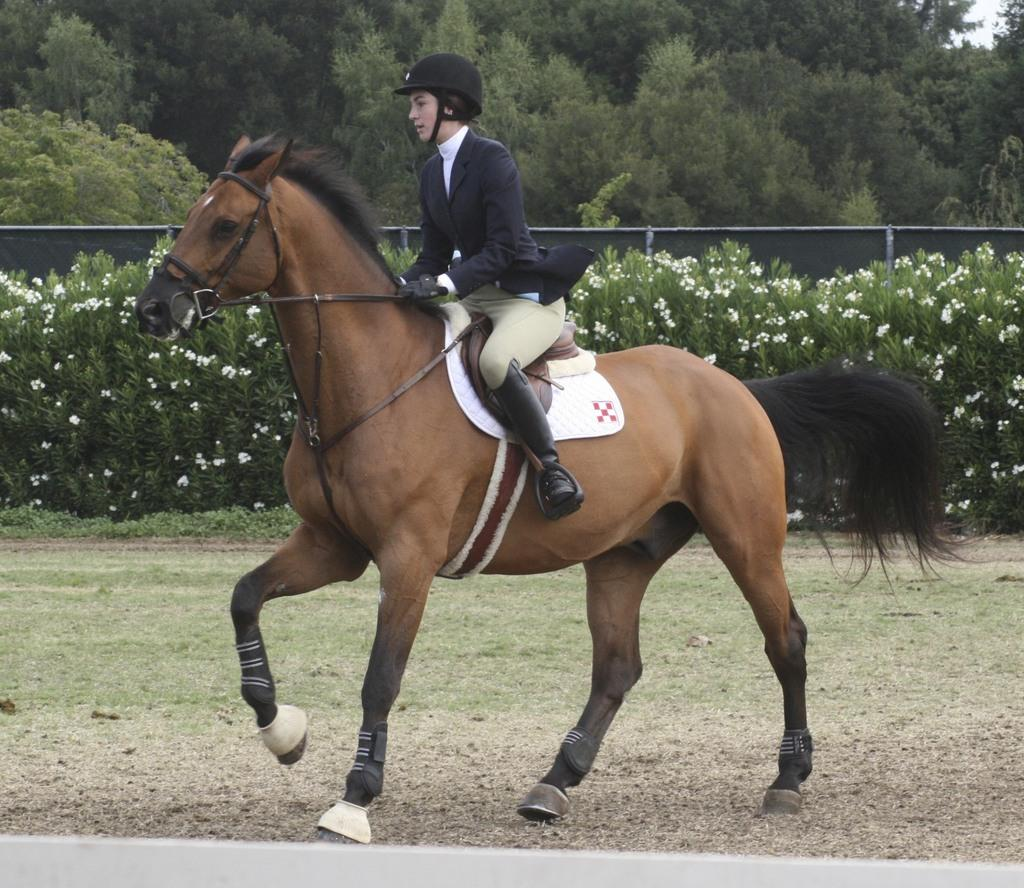What is the main subject of the image? The main subject of the image is a person riding a horse. What protective gear is the person wearing? The person is wearing a helmet. What can be seen in the background of the image? There are plants and railing in the background of the image. What type of vegetation is present in the image? Trees are present in the image. What type of star can be seen shining brightly in the image? There is no star visible in the image; it features a person riding a horse with a helmet, plants, railing, and trees in the background. What type of beam is supporting the railing in the image? There is no beam supporting the railing in the image; only the railing itself is visible in the background. 